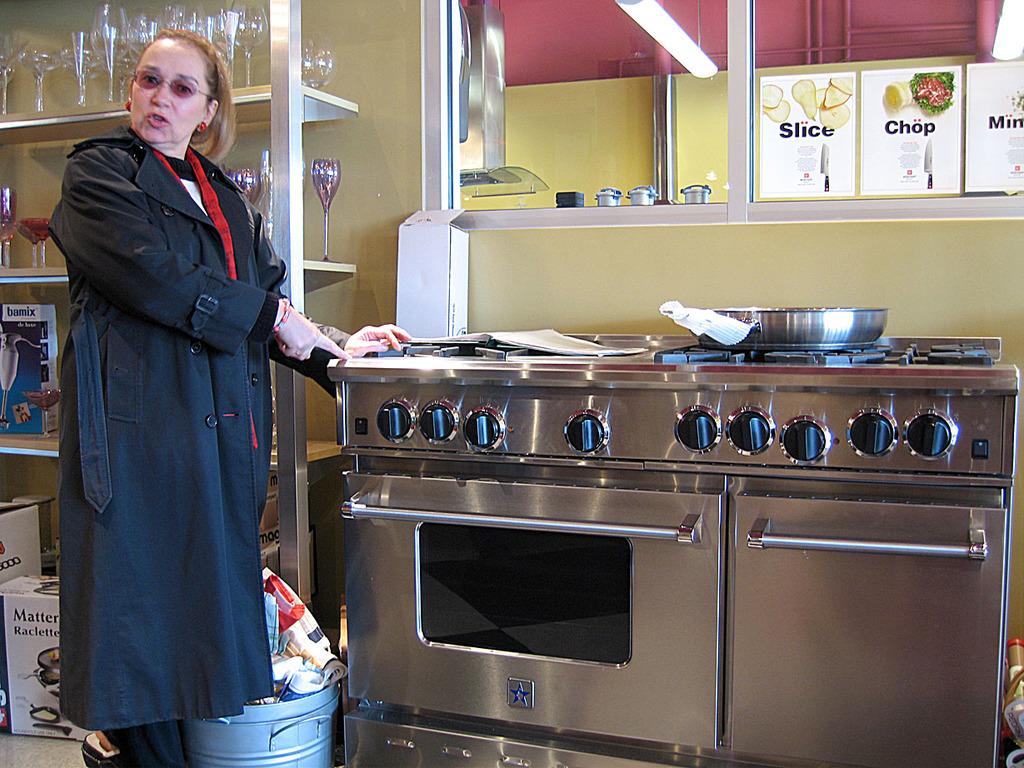What verb is labeled on the first box above the stove?
Provide a succinct answer. Slice. Whats the name of the brand of the mixer on the shelf?
Your response must be concise. Unanswerable. 